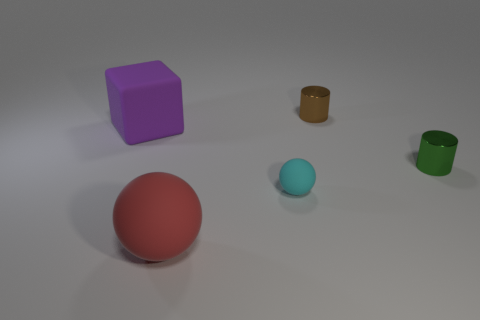Add 1 small cyan metal spheres. How many objects exist? 6 Subtract all red spheres. How many spheres are left? 1 Subtract all gray cylinders. Subtract all brown cubes. How many cylinders are left? 2 Subtract all gray balls. How many brown cylinders are left? 1 Subtract all small gray blocks. Subtract all green objects. How many objects are left? 4 Add 2 purple matte cubes. How many purple matte cubes are left? 3 Add 3 brown blocks. How many brown blocks exist? 3 Subtract 0 blue blocks. How many objects are left? 5 Subtract all balls. How many objects are left? 3 